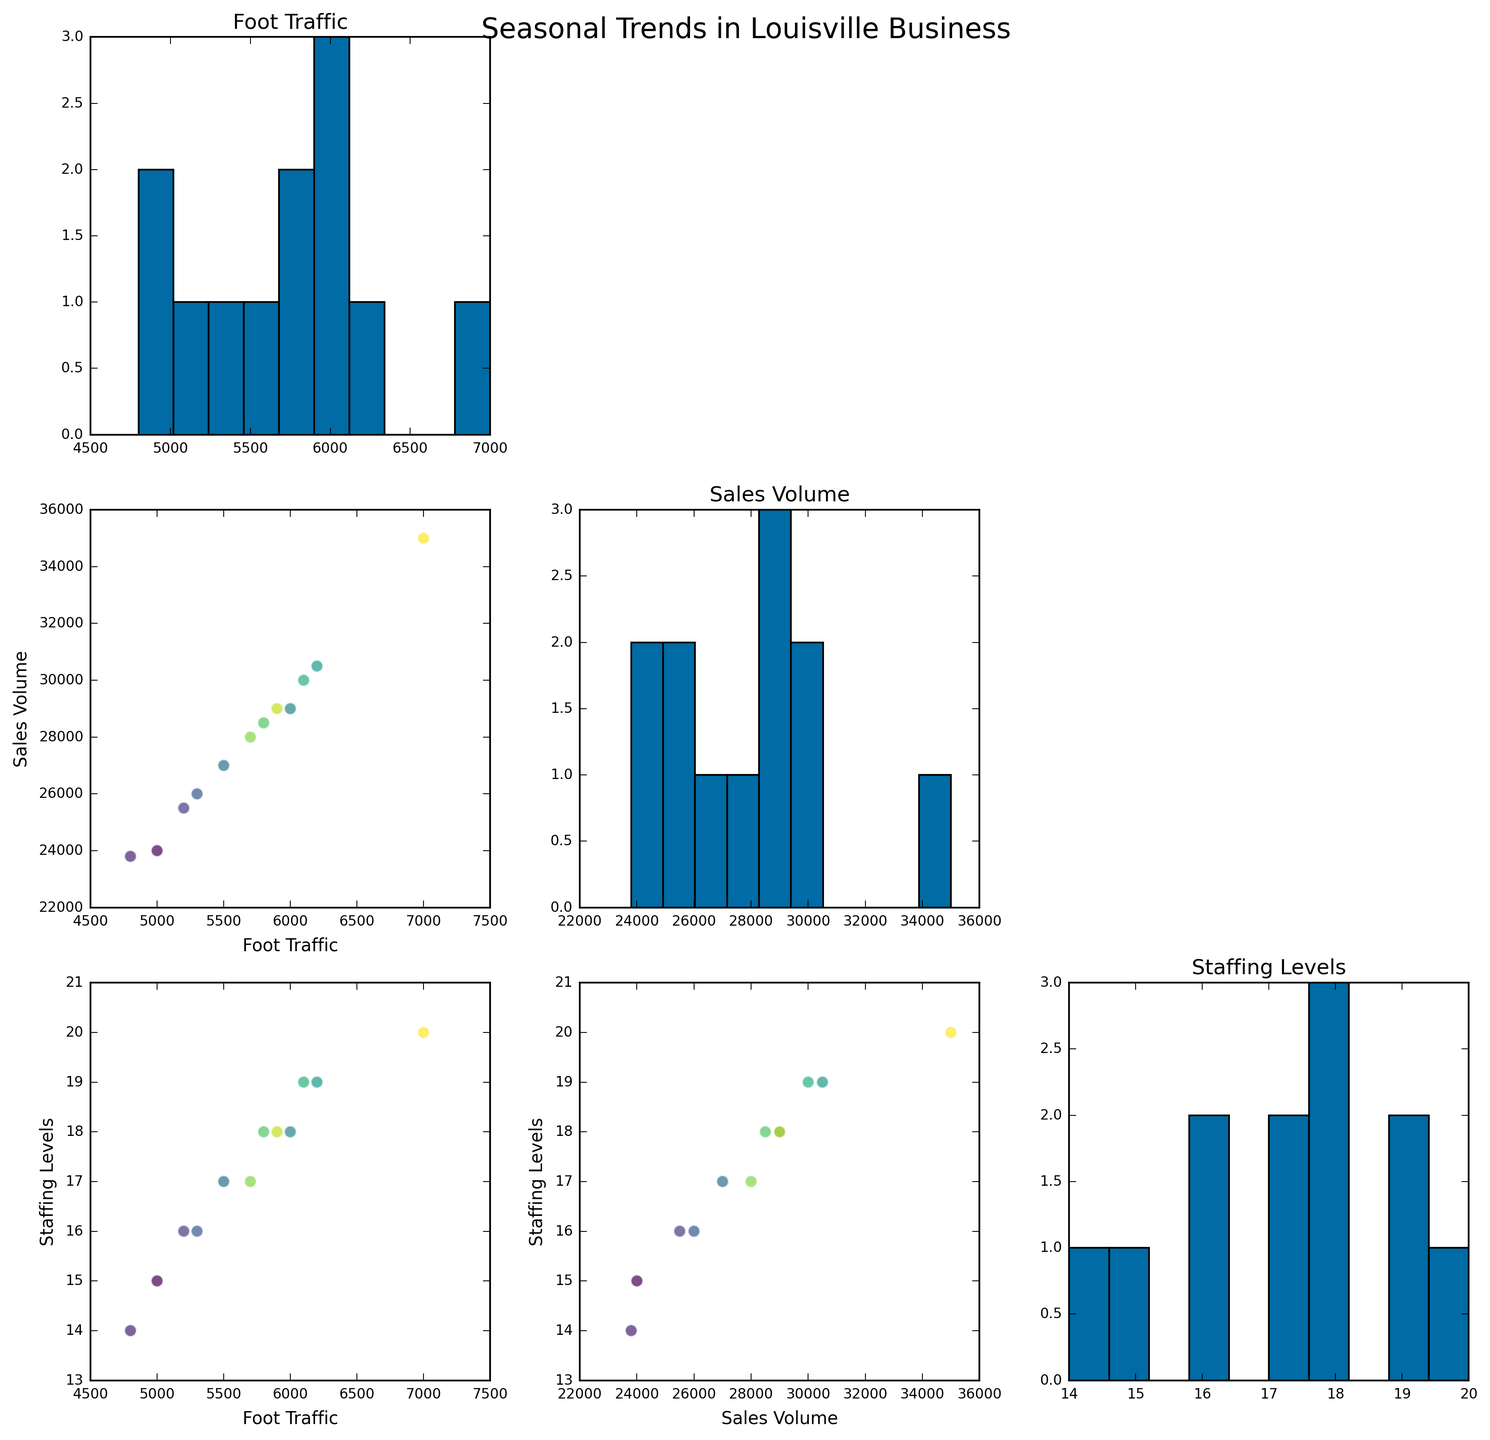How many scatter plots are present in the figure? Each pair of variables (Foot Traffic, Sales Volume, Staffing Levels) results in one scatter plot. There are 3 variables, so the combination of pairs is (3 choose 2) = 3 scatter plots.
Answer: 3 Which month likely has the highest foot traffic? By looking at the histogram for Foot Traffic, the tallest bar indicates the highest value. December has the highest value of 7000.
Answer: December What general trend is observed between Foot Traffic and Sales Volume? The scatter plot of Foot Traffic vs. Sales Volume shows a positive correlation, meaning as Foot Traffic increases, Sales Volume also tends to increase.
Answer: Positive Correlation Is there any visible trend between Staffing Levels and Sales Volume? The scatter plot of Staffing Levels vs. Sales Volume shows a positive correlation. Higher Staffing Levels generally correlate with higher Sales Volume.
Answer: Positive Correlation In which range do most of the Staffing Levels fall? By examining the histogram for Staffing Levels, most of the data points are grouped between 15 and 20 staff members.
Answer: 15 to 20 Which pair of variables has the strongest positive correlation? Comparing the scatter plots, Staffing Levels vs. Sales Volume shows the most tightly grouped points with a clear positive trend, indicating the strongest positive correlation.
Answer: Staffing Levels and Sales Volume During which month is the variation in Sales Volume the highest? The scatter plot of Sales Volume would show the highest variation in the month with the highest sales, which is December with a maximum sales value of 35000.
Answer: December What pattern can be observed in the Foot Traffic across different months? The histogram for Foot Traffic reveals an increase from January to December, with a noticeable peak in December.
Answer: Increasing Trend Which variable shows the least variation throughout the year? By comparing the histograms, Staffing Levels has the least spread and resembles more concentrated bars, indicating less variation compared to Foot Traffic and Sales Volume.
Answer: Staffing Levels How does the Sales Volume in February compare to July? Observing both the scatter plots and histograms, Sales Volume in February is around 23800, whereas in July it's approximately 30500. July has higher Sales Volume than February.
Answer: July has higher Sales Volume 